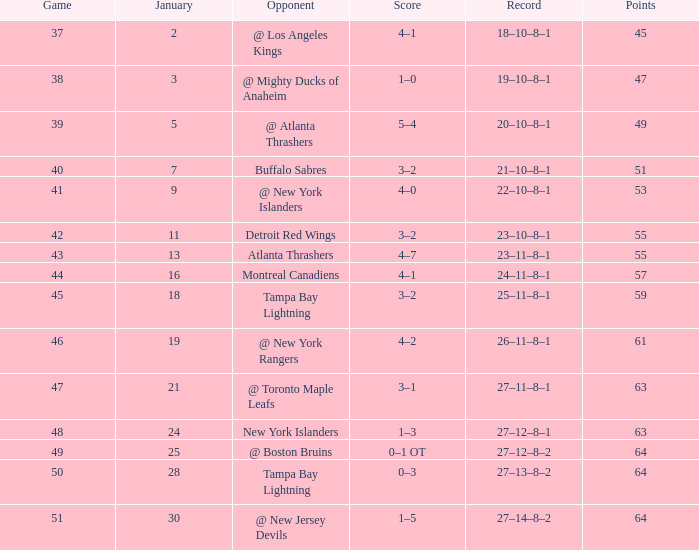What is the number of points in january that have 18? 1.0. 